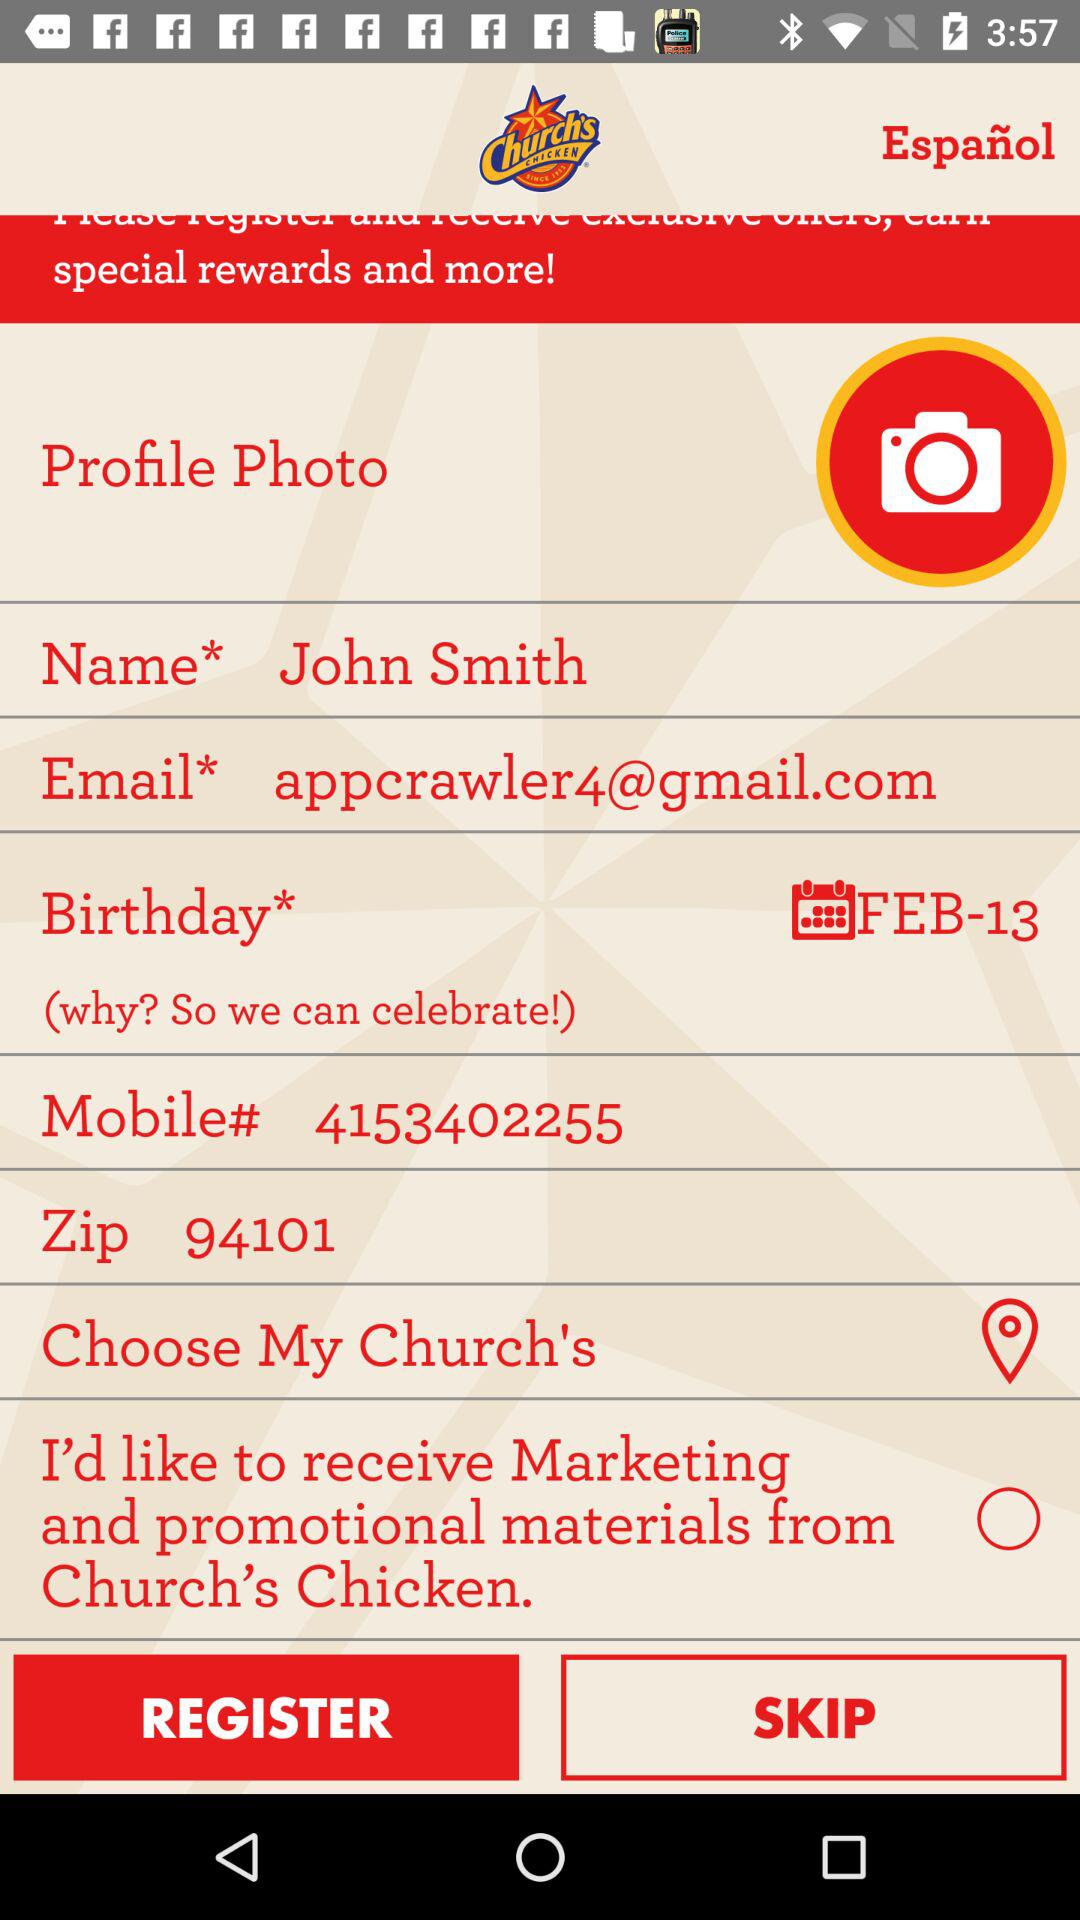What is the Zip code? The Zip code is 94101. 